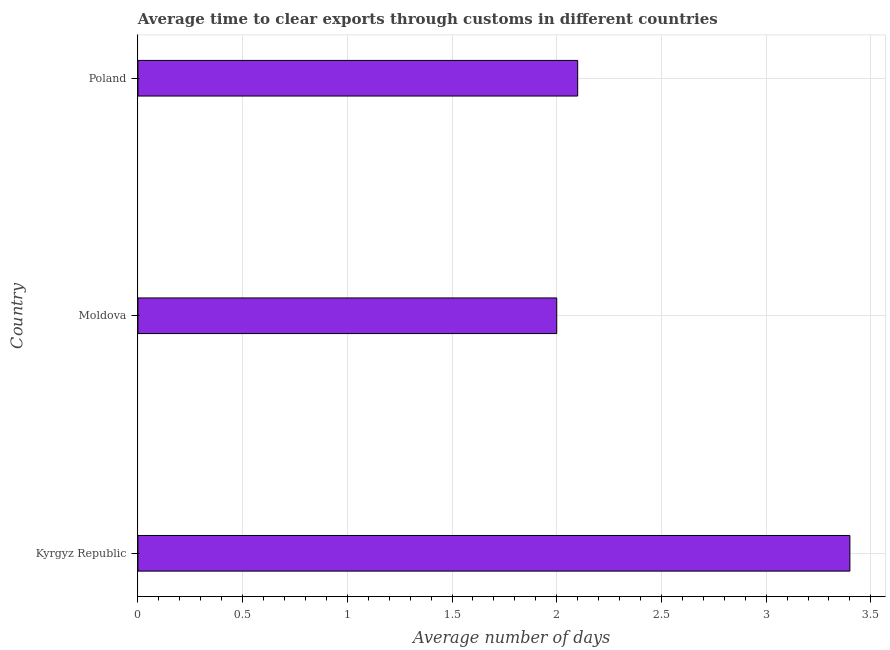Does the graph contain grids?
Your response must be concise. Yes. What is the title of the graph?
Provide a short and direct response. Average time to clear exports through customs in different countries. What is the label or title of the X-axis?
Provide a succinct answer. Average number of days. Across all countries, what is the minimum time to clear exports through customs?
Offer a terse response. 2. In which country was the time to clear exports through customs maximum?
Keep it short and to the point. Kyrgyz Republic. In which country was the time to clear exports through customs minimum?
Your response must be concise. Moldova. What is the ratio of the time to clear exports through customs in Kyrgyz Republic to that in Poland?
Keep it short and to the point. 1.62. Is the time to clear exports through customs in Kyrgyz Republic less than that in Poland?
Provide a short and direct response. No. Is the difference between the time to clear exports through customs in Kyrgyz Republic and Moldova greater than the difference between any two countries?
Provide a short and direct response. Yes. What is the difference between the highest and the lowest time to clear exports through customs?
Offer a very short reply. 1.4. How many countries are there in the graph?
Make the answer very short. 3. What is the difference between two consecutive major ticks on the X-axis?
Make the answer very short. 0.5. Are the values on the major ticks of X-axis written in scientific E-notation?
Offer a very short reply. No. What is the Average number of days of Kyrgyz Republic?
Your answer should be very brief. 3.4. What is the Average number of days in Moldova?
Your answer should be compact. 2. What is the difference between the Average number of days in Kyrgyz Republic and Moldova?
Your response must be concise. 1.4. What is the ratio of the Average number of days in Kyrgyz Republic to that in Poland?
Offer a very short reply. 1.62. 